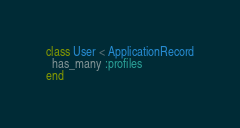<code> <loc_0><loc_0><loc_500><loc_500><_Ruby_>class User < ApplicationRecord
  has_many :profiles
end
</code> 